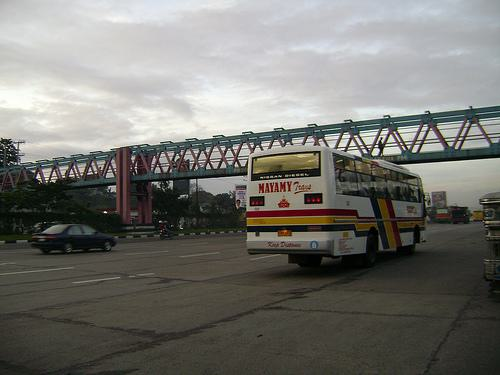Can you tell me more about the bridge in the background? The red pedestrian bridge in the background has a modern truss design, typically used for its strong, lightweight structure. It serves as a visually interesting element in the composition of this urban setting. 